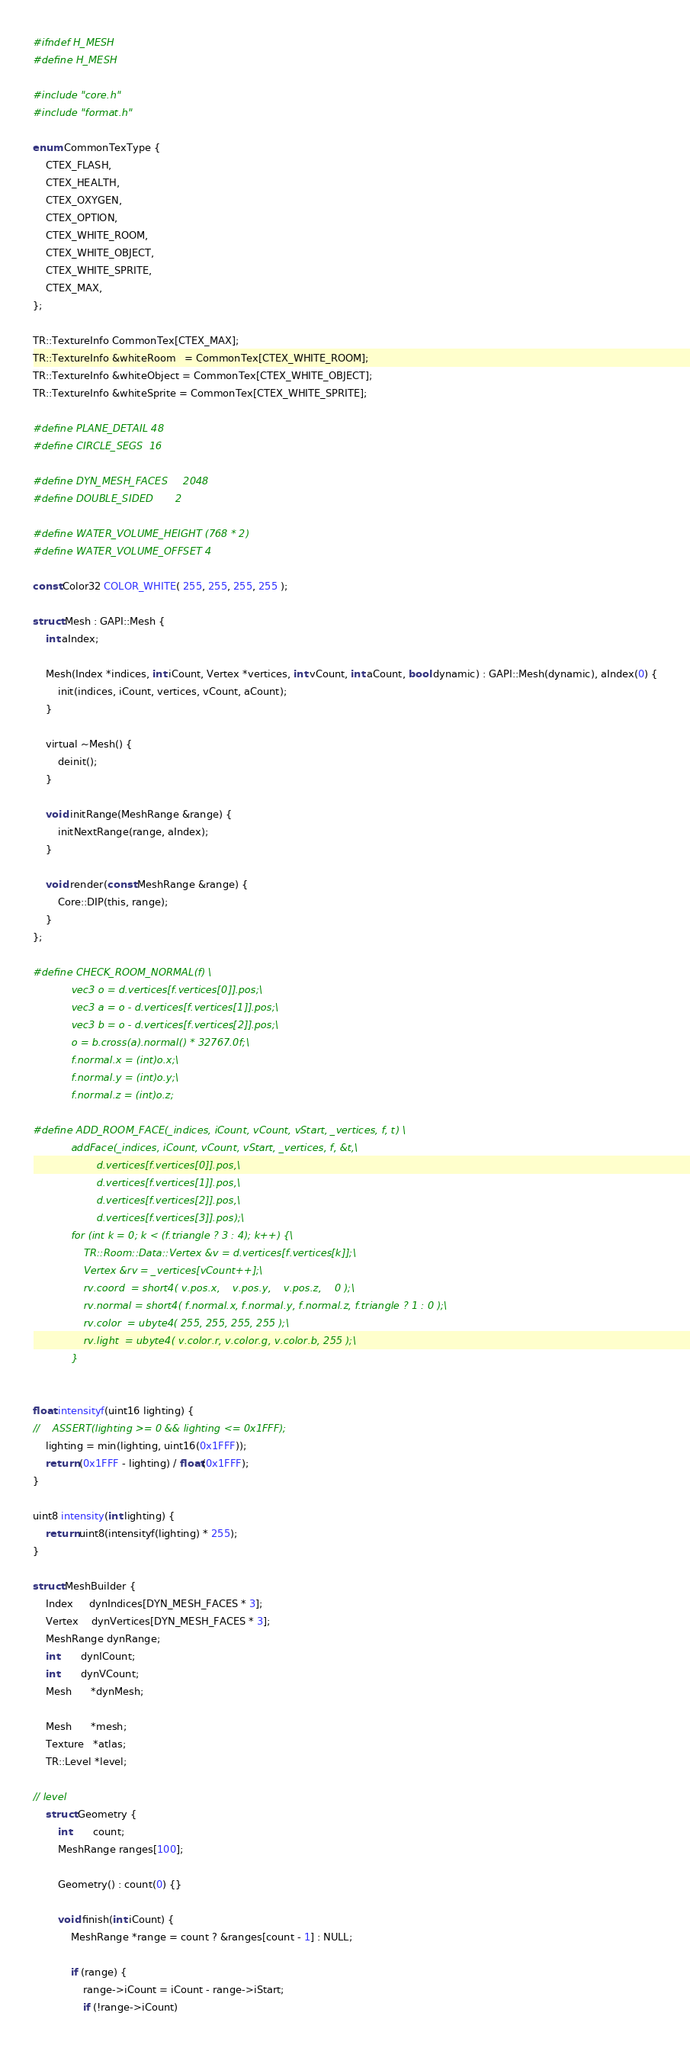<code> <loc_0><loc_0><loc_500><loc_500><_C_>#ifndef H_MESH
#define H_MESH

#include "core.h"
#include "format.h"

enum CommonTexType {
    CTEX_FLASH,
    CTEX_HEALTH,
    CTEX_OXYGEN,
    CTEX_OPTION,
    CTEX_WHITE_ROOM,
    CTEX_WHITE_OBJECT,
    CTEX_WHITE_SPRITE,
    CTEX_MAX,
};

TR::TextureInfo CommonTex[CTEX_MAX];
TR::TextureInfo &whiteRoom   = CommonTex[CTEX_WHITE_ROOM];
TR::TextureInfo &whiteObject = CommonTex[CTEX_WHITE_OBJECT];
TR::TextureInfo &whiteSprite = CommonTex[CTEX_WHITE_SPRITE];

#define PLANE_DETAIL 48
#define CIRCLE_SEGS  16

#define DYN_MESH_FACES     2048
#define DOUBLE_SIDED       2

#define WATER_VOLUME_HEIGHT (768 * 2)
#define WATER_VOLUME_OFFSET 4

const Color32 COLOR_WHITE( 255, 255, 255, 255 );

struct Mesh : GAPI::Mesh {
    int aIndex;

    Mesh(Index *indices, int iCount, Vertex *vertices, int vCount, int aCount, bool dynamic) : GAPI::Mesh(dynamic), aIndex(0) {
        init(indices, iCount, vertices, vCount, aCount);
    }

    virtual ~Mesh() {
        deinit();
    }

    void initRange(MeshRange &range) {
        initNextRange(range, aIndex);
    }

    void render(const MeshRange &range) {
        Core::DIP(this, range);
    }
};

#define CHECK_ROOM_NORMAL(f) \
            vec3 o = d.vertices[f.vertices[0]].pos;\
            vec3 a = o - d.vertices[f.vertices[1]].pos;\
            vec3 b = o - d.vertices[f.vertices[2]].pos;\
            o = b.cross(a).normal() * 32767.0f;\
            f.normal.x = (int)o.x;\
            f.normal.y = (int)o.y;\
            f.normal.z = (int)o.z;

#define ADD_ROOM_FACE(_indices, iCount, vCount, vStart, _vertices, f, t) \
            addFace(_indices, iCount, vCount, vStart, _vertices, f, &t,\
                    d.vertices[f.vertices[0]].pos,\
                    d.vertices[f.vertices[1]].pos,\
                    d.vertices[f.vertices[2]].pos,\
                    d.vertices[f.vertices[3]].pos);\
            for (int k = 0; k < (f.triangle ? 3 : 4); k++) {\
                TR::Room::Data::Vertex &v = d.vertices[f.vertices[k]];\
                Vertex &rv = _vertices[vCount++];\
                rv.coord  = short4( v.pos.x,    v.pos.y,    v.pos.z,    0 );\
                rv.normal = short4( f.normal.x, f.normal.y, f.normal.z, f.triangle ? 1 : 0 );\
                rv.color  = ubyte4( 255, 255, 255, 255 );\
                rv.light  = ubyte4( v.color.r, v.color.g, v.color.b, 255 );\
            }


float intensityf(uint16 lighting) {
//    ASSERT(lighting >= 0 && lighting <= 0x1FFF);
    lighting = min(lighting, uint16(0x1FFF));
    return (0x1FFF - lighting) / float(0x1FFF);
}

uint8 intensity(int lighting) {
    return uint8(intensityf(lighting) * 255);
}

struct MeshBuilder {
    Index     dynIndices[DYN_MESH_FACES * 3];
    Vertex    dynVertices[DYN_MESH_FACES * 3];
    MeshRange dynRange;
    int       dynICount;
    int       dynVCount;
    Mesh      *dynMesh;

    Mesh      *mesh;
    Texture   *atlas;
    TR::Level *level;

// level
    struct Geometry {
        int       count;
        MeshRange ranges[100];

        Geometry() : count(0) {}

        void finish(int iCount) {
            MeshRange *range = count ? &ranges[count - 1] : NULL;

            if (range) {
                range->iCount = iCount - range->iStart;
                if (!range->iCount)</code> 